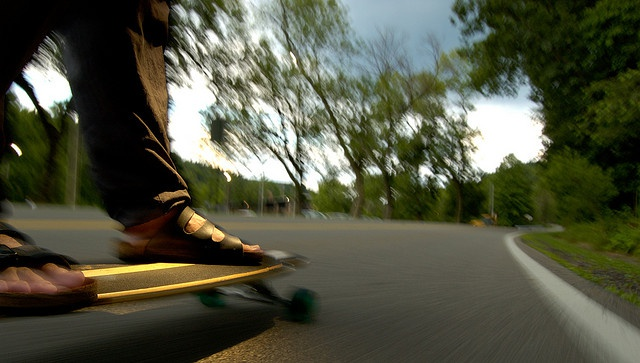Describe the objects in this image and their specific colors. I can see people in black, maroon, and gray tones and skateboard in black and olive tones in this image. 